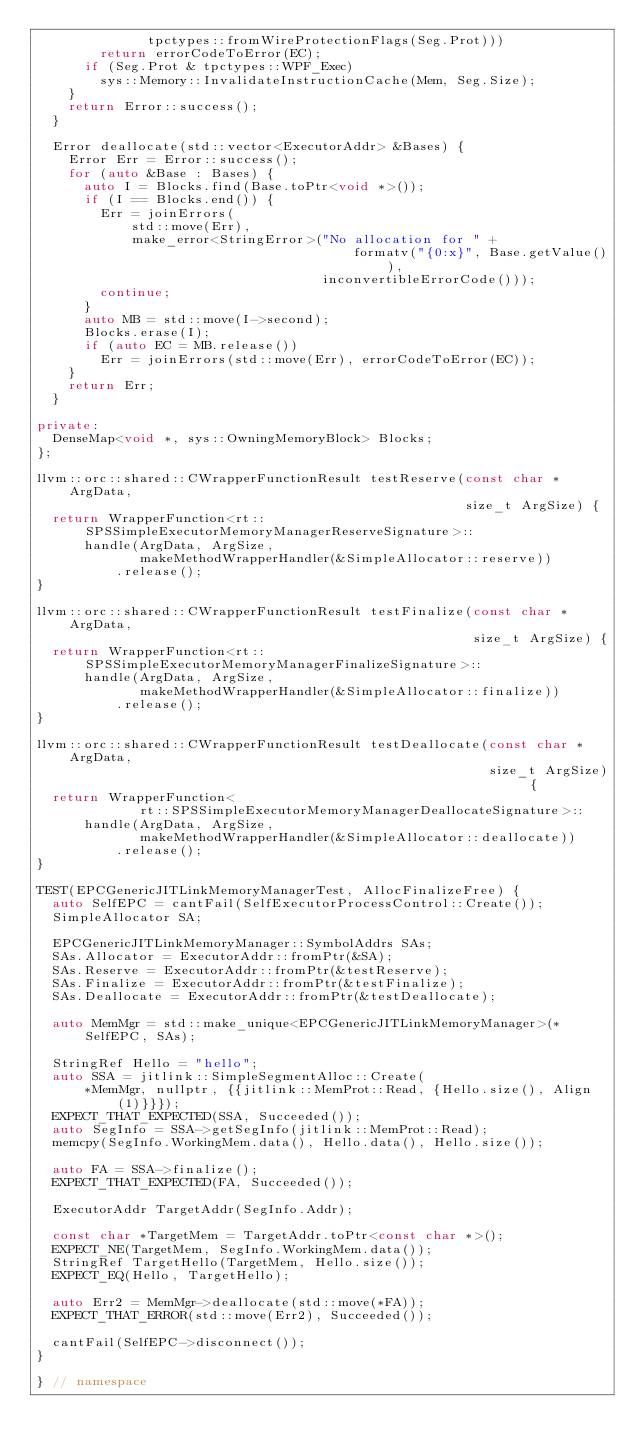Convert code to text. <code><loc_0><loc_0><loc_500><loc_500><_C++_>              tpctypes::fromWireProtectionFlags(Seg.Prot)))
        return errorCodeToError(EC);
      if (Seg.Prot & tpctypes::WPF_Exec)
        sys::Memory::InvalidateInstructionCache(Mem, Seg.Size);
    }
    return Error::success();
  }

  Error deallocate(std::vector<ExecutorAddr> &Bases) {
    Error Err = Error::success();
    for (auto &Base : Bases) {
      auto I = Blocks.find(Base.toPtr<void *>());
      if (I == Blocks.end()) {
        Err = joinErrors(
            std::move(Err),
            make_error<StringError>("No allocation for " +
                                        formatv("{0:x}", Base.getValue()),
                                    inconvertibleErrorCode()));
        continue;
      }
      auto MB = std::move(I->second);
      Blocks.erase(I);
      if (auto EC = MB.release())
        Err = joinErrors(std::move(Err), errorCodeToError(EC));
    }
    return Err;
  }

private:
  DenseMap<void *, sys::OwningMemoryBlock> Blocks;
};

llvm::orc::shared::CWrapperFunctionResult testReserve(const char *ArgData,
                                                      size_t ArgSize) {
  return WrapperFunction<rt::SPSSimpleExecutorMemoryManagerReserveSignature>::
      handle(ArgData, ArgSize,
             makeMethodWrapperHandler(&SimpleAllocator::reserve))
          .release();
}

llvm::orc::shared::CWrapperFunctionResult testFinalize(const char *ArgData,
                                                       size_t ArgSize) {
  return WrapperFunction<rt::SPSSimpleExecutorMemoryManagerFinalizeSignature>::
      handle(ArgData, ArgSize,
             makeMethodWrapperHandler(&SimpleAllocator::finalize))
          .release();
}

llvm::orc::shared::CWrapperFunctionResult testDeallocate(const char *ArgData,
                                                         size_t ArgSize) {
  return WrapperFunction<
             rt::SPSSimpleExecutorMemoryManagerDeallocateSignature>::
      handle(ArgData, ArgSize,
             makeMethodWrapperHandler(&SimpleAllocator::deallocate))
          .release();
}

TEST(EPCGenericJITLinkMemoryManagerTest, AllocFinalizeFree) {
  auto SelfEPC = cantFail(SelfExecutorProcessControl::Create());
  SimpleAllocator SA;

  EPCGenericJITLinkMemoryManager::SymbolAddrs SAs;
  SAs.Allocator = ExecutorAddr::fromPtr(&SA);
  SAs.Reserve = ExecutorAddr::fromPtr(&testReserve);
  SAs.Finalize = ExecutorAddr::fromPtr(&testFinalize);
  SAs.Deallocate = ExecutorAddr::fromPtr(&testDeallocate);

  auto MemMgr = std::make_unique<EPCGenericJITLinkMemoryManager>(*SelfEPC, SAs);

  StringRef Hello = "hello";
  auto SSA = jitlink::SimpleSegmentAlloc::Create(
      *MemMgr, nullptr, {{jitlink::MemProt::Read, {Hello.size(), Align(1)}}});
  EXPECT_THAT_EXPECTED(SSA, Succeeded());
  auto SegInfo = SSA->getSegInfo(jitlink::MemProt::Read);
  memcpy(SegInfo.WorkingMem.data(), Hello.data(), Hello.size());

  auto FA = SSA->finalize();
  EXPECT_THAT_EXPECTED(FA, Succeeded());

  ExecutorAddr TargetAddr(SegInfo.Addr);

  const char *TargetMem = TargetAddr.toPtr<const char *>();
  EXPECT_NE(TargetMem, SegInfo.WorkingMem.data());
  StringRef TargetHello(TargetMem, Hello.size());
  EXPECT_EQ(Hello, TargetHello);

  auto Err2 = MemMgr->deallocate(std::move(*FA));
  EXPECT_THAT_ERROR(std::move(Err2), Succeeded());

  cantFail(SelfEPC->disconnect());
}

} // namespace
</code> 